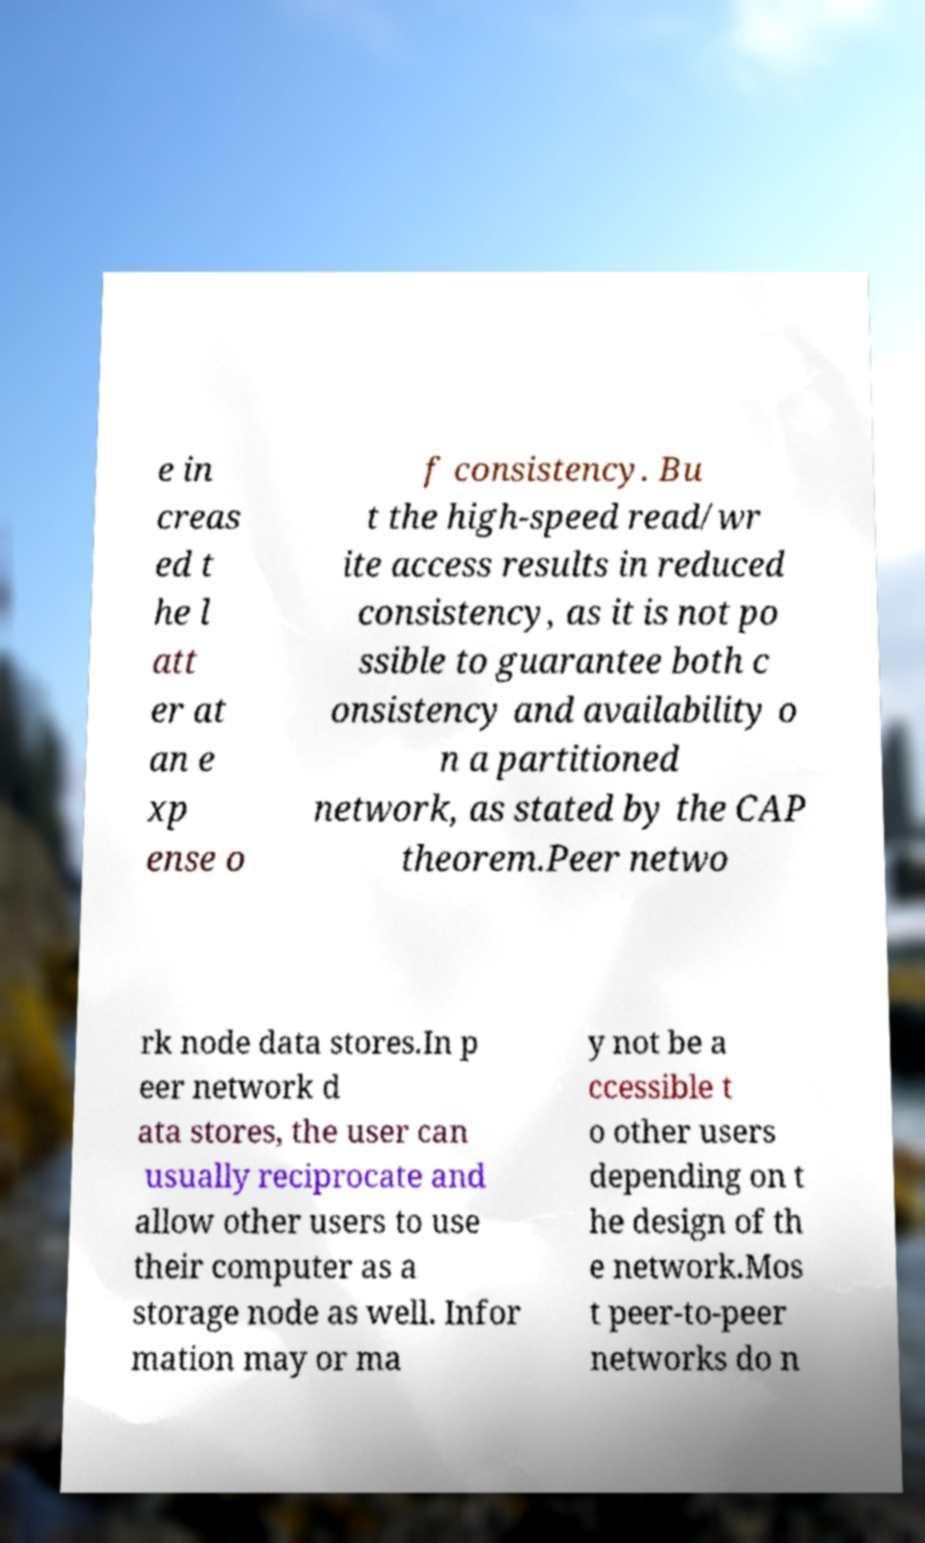There's text embedded in this image that I need extracted. Can you transcribe it verbatim? e in creas ed t he l att er at an e xp ense o f consistency. Bu t the high-speed read/wr ite access results in reduced consistency, as it is not po ssible to guarantee both c onsistency and availability o n a partitioned network, as stated by the CAP theorem.Peer netwo rk node data stores.In p eer network d ata stores, the user can usually reciprocate and allow other users to use their computer as a storage node as well. Infor mation may or ma y not be a ccessible t o other users depending on t he design of th e network.Mos t peer-to-peer networks do n 